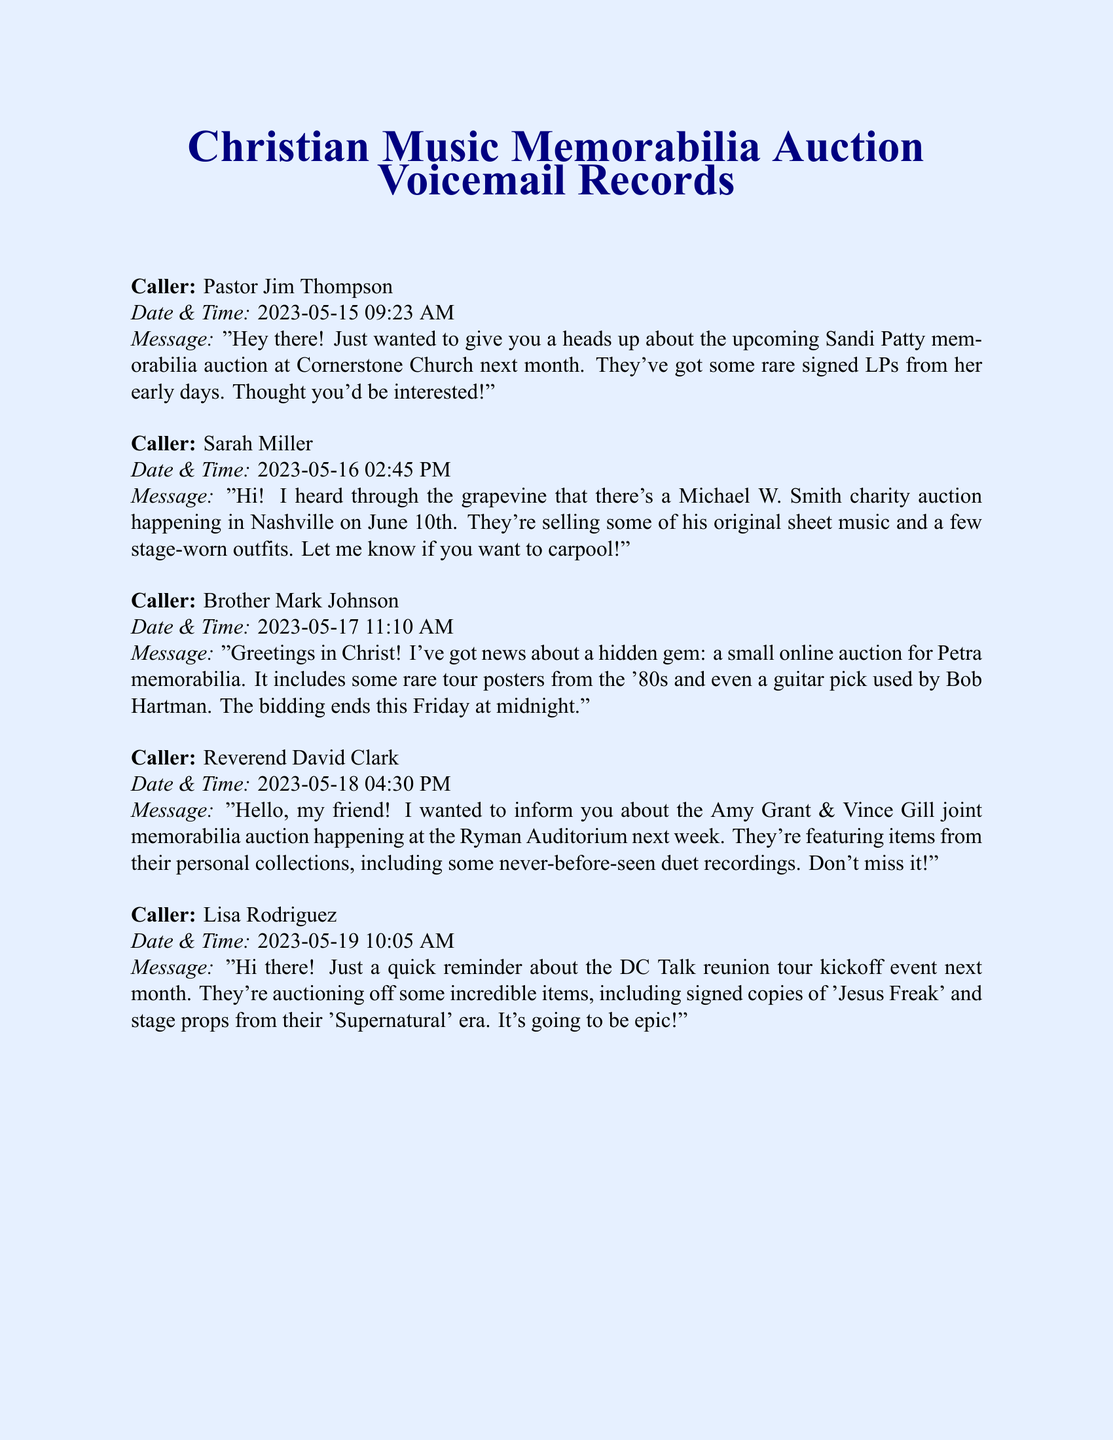what is the date of the Sandi Patty memorabilia auction? The Sandi Patty memorabilia auction is scheduled for the next month after the message was left, which is in June 2023.
Answer: June 2023 who called about the Michael W. Smith charity auction? The message regarding the Michael W. Smith charity auction was left by Sarah Miller.
Answer: Sarah Miller what is the deadline for the Petra memorabilia auction bids? The bids for the Petra memorabilia auction end at midnight on Friday after the message was left.
Answer: Friday at midnight where is the Amy Grant & Vince Gill joint memorabilia auction taking place? The auction is happening at the Ryman Auditorium.
Answer: Ryman Auditorium how many items from personal collections are being featured in the Amy Grant & Vince Gill auction? The specific number of items from their personal collections isn’t mentioned, but it includes several never-before-seen duet recordings.
Answer: Several which item related to DC Talk is mentioned in Lisa Rodriguez's message? The message mentions signed copies of 'Jesus Freak.'
Answer: signed copies of 'Jesus Freak' who provided information about a small online auction? Brother Mark Johnson provided information about the small online auction.
Answer: Brother Mark Johnson when did Reverend David Clark leave his message? Reverend David Clark left his message on May 18, 2023, at 4:30 PM.
Answer: May 18, 2023, at 4:30 PM 